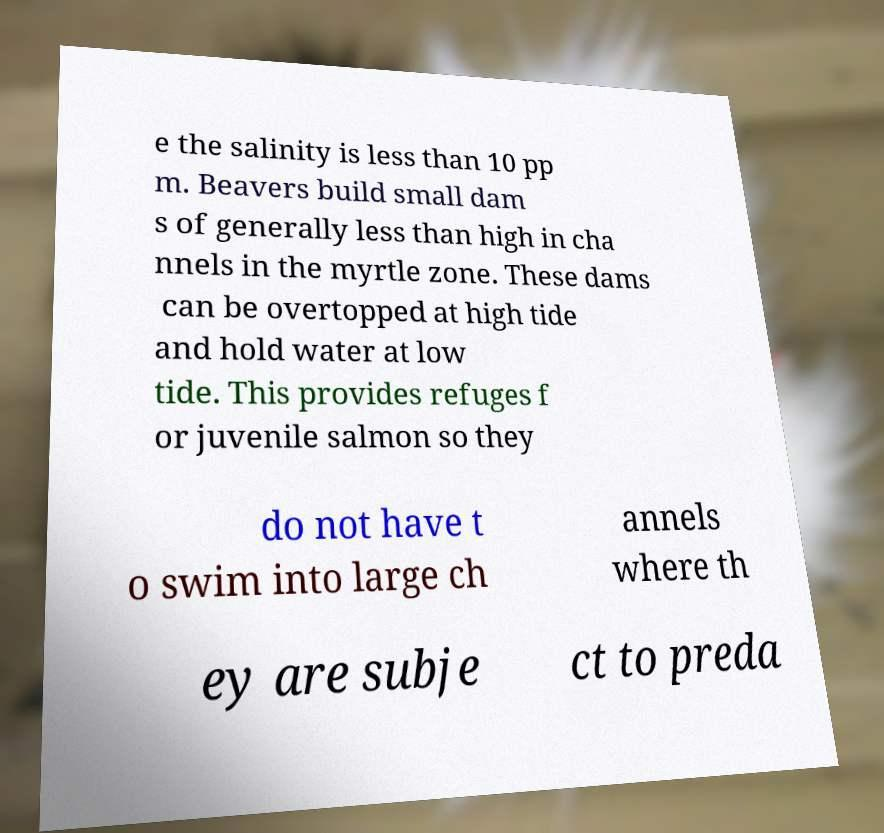I need the written content from this picture converted into text. Can you do that? e the salinity is less than 10 pp m. Beavers build small dam s of generally less than high in cha nnels in the myrtle zone. These dams can be overtopped at high tide and hold water at low tide. This provides refuges f or juvenile salmon so they do not have t o swim into large ch annels where th ey are subje ct to preda 